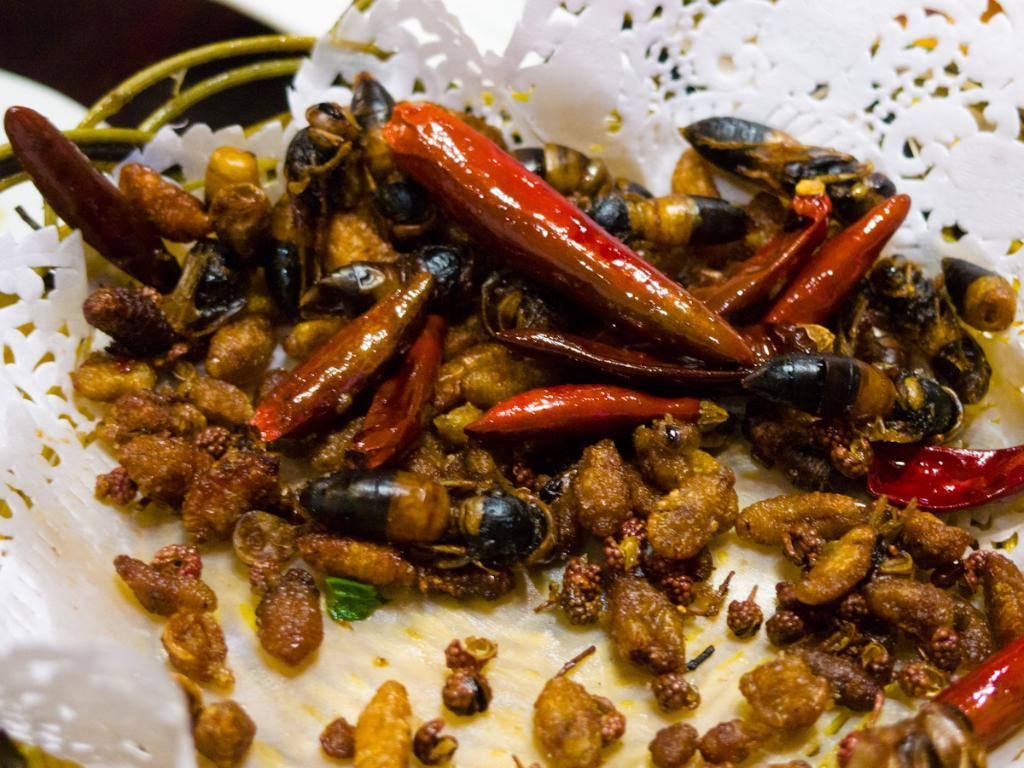What is on the plate that is visible in the image? There is food on a plate in the image. Where is the plate located in the image? The plate is in the center of the image. What type of yak can be seen wearing a boot on its trip in the image? There is no yak, boot, or trip present in the image; it only features a plate of food in the center. 